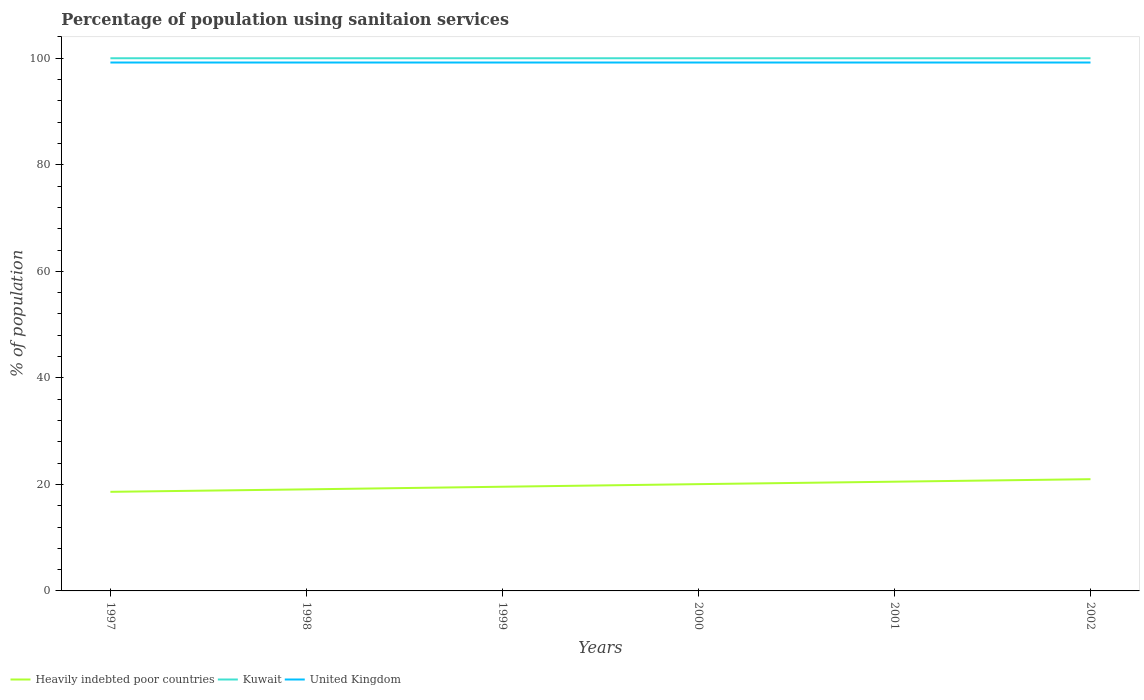Does the line corresponding to Heavily indebted poor countries intersect with the line corresponding to United Kingdom?
Ensure brevity in your answer.  No. Is the number of lines equal to the number of legend labels?
Offer a very short reply. Yes. Across all years, what is the maximum percentage of population using sanitaion services in Kuwait?
Your response must be concise. 100. What is the total percentage of population using sanitaion services in Heavily indebted poor countries in the graph?
Keep it short and to the point. -1.91. What is the difference between the highest and the lowest percentage of population using sanitaion services in Kuwait?
Make the answer very short. 0. Is the percentage of population using sanitaion services in Kuwait strictly greater than the percentage of population using sanitaion services in Heavily indebted poor countries over the years?
Offer a very short reply. No. How many years are there in the graph?
Keep it short and to the point. 6. Are the values on the major ticks of Y-axis written in scientific E-notation?
Provide a short and direct response. No. Does the graph contain any zero values?
Your response must be concise. No. How are the legend labels stacked?
Keep it short and to the point. Horizontal. What is the title of the graph?
Ensure brevity in your answer.  Percentage of population using sanitaion services. Does "Arab World" appear as one of the legend labels in the graph?
Make the answer very short. No. What is the label or title of the X-axis?
Your answer should be compact. Years. What is the label or title of the Y-axis?
Offer a terse response. % of population. What is the % of population in Heavily indebted poor countries in 1997?
Provide a succinct answer. 18.6. What is the % of population of United Kingdom in 1997?
Your response must be concise. 99.2. What is the % of population of Heavily indebted poor countries in 1998?
Offer a very short reply. 19.07. What is the % of population of Kuwait in 1998?
Provide a short and direct response. 100. What is the % of population of United Kingdom in 1998?
Make the answer very short. 99.2. What is the % of population in Heavily indebted poor countries in 1999?
Your answer should be compact. 19.56. What is the % of population of United Kingdom in 1999?
Your response must be concise. 99.2. What is the % of population of Heavily indebted poor countries in 2000?
Keep it short and to the point. 20.05. What is the % of population of Kuwait in 2000?
Your answer should be very brief. 100. What is the % of population in United Kingdom in 2000?
Keep it short and to the point. 99.2. What is the % of population in Heavily indebted poor countries in 2001?
Your answer should be very brief. 20.51. What is the % of population in United Kingdom in 2001?
Make the answer very short. 99.2. What is the % of population in Heavily indebted poor countries in 2002?
Provide a succinct answer. 20.98. What is the % of population in Kuwait in 2002?
Keep it short and to the point. 100. What is the % of population of United Kingdom in 2002?
Keep it short and to the point. 99.2. Across all years, what is the maximum % of population of Heavily indebted poor countries?
Provide a short and direct response. 20.98. Across all years, what is the maximum % of population of Kuwait?
Your answer should be very brief. 100. Across all years, what is the maximum % of population in United Kingdom?
Offer a very short reply. 99.2. Across all years, what is the minimum % of population in Heavily indebted poor countries?
Offer a terse response. 18.6. Across all years, what is the minimum % of population of United Kingdom?
Provide a succinct answer. 99.2. What is the total % of population of Heavily indebted poor countries in the graph?
Your response must be concise. 118.76. What is the total % of population in Kuwait in the graph?
Offer a terse response. 600. What is the total % of population in United Kingdom in the graph?
Your response must be concise. 595.2. What is the difference between the % of population in Heavily indebted poor countries in 1997 and that in 1998?
Ensure brevity in your answer.  -0.46. What is the difference between the % of population of United Kingdom in 1997 and that in 1998?
Provide a succinct answer. 0. What is the difference between the % of population of Heavily indebted poor countries in 1997 and that in 1999?
Your response must be concise. -0.96. What is the difference between the % of population of Heavily indebted poor countries in 1997 and that in 2000?
Offer a very short reply. -1.44. What is the difference between the % of population in Kuwait in 1997 and that in 2000?
Offer a terse response. 0. What is the difference between the % of population of Heavily indebted poor countries in 1997 and that in 2001?
Give a very brief answer. -1.9. What is the difference between the % of population in Kuwait in 1997 and that in 2001?
Keep it short and to the point. 0. What is the difference between the % of population of United Kingdom in 1997 and that in 2001?
Offer a terse response. 0. What is the difference between the % of population of Heavily indebted poor countries in 1997 and that in 2002?
Offer a very short reply. -2.37. What is the difference between the % of population of Kuwait in 1997 and that in 2002?
Offer a terse response. 0. What is the difference between the % of population of Heavily indebted poor countries in 1998 and that in 1999?
Provide a succinct answer. -0.49. What is the difference between the % of population in United Kingdom in 1998 and that in 1999?
Offer a terse response. 0. What is the difference between the % of population in Heavily indebted poor countries in 1998 and that in 2000?
Provide a short and direct response. -0.98. What is the difference between the % of population in United Kingdom in 1998 and that in 2000?
Ensure brevity in your answer.  0. What is the difference between the % of population in Heavily indebted poor countries in 1998 and that in 2001?
Offer a terse response. -1.44. What is the difference between the % of population in Kuwait in 1998 and that in 2001?
Ensure brevity in your answer.  0. What is the difference between the % of population in United Kingdom in 1998 and that in 2001?
Your response must be concise. 0. What is the difference between the % of population in Heavily indebted poor countries in 1998 and that in 2002?
Your answer should be compact. -1.91. What is the difference between the % of population of Kuwait in 1998 and that in 2002?
Give a very brief answer. 0. What is the difference between the % of population in Heavily indebted poor countries in 1999 and that in 2000?
Keep it short and to the point. -0.49. What is the difference between the % of population of Kuwait in 1999 and that in 2000?
Your answer should be compact. 0. What is the difference between the % of population of Heavily indebted poor countries in 1999 and that in 2001?
Provide a succinct answer. -0.95. What is the difference between the % of population of Heavily indebted poor countries in 1999 and that in 2002?
Your answer should be very brief. -1.42. What is the difference between the % of population of United Kingdom in 1999 and that in 2002?
Make the answer very short. 0. What is the difference between the % of population in Heavily indebted poor countries in 2000 and that in 2001?
Offer a terse response. -0.46. What is the difference between the % of population of Heavily indebted poor countries in 2000 and that in 2002?
Your answer should be very brief. -0.93. What is the difference between the % of population of Kuwait in 2000 and that in 2002?
Provide a short and direct response. 0. What is the difference between the % of population of United Kingdom in 2000 and that in 2002?
Offer a very short reply. 0. What is the difference between the % of population of Heavily indebted poor countries in 2001 and that in 2002?
Make the answer very short. -0.47. What is the difference between the % of population of Kuwait in 2001 and that in 2002?
Provide a short and direct response. 0. What is the difference between the % of population in United Kingdom in 2001 and that in 2002?
Provide a short and direct response. 0. What is the difference between the % of population in Heavily indebted poor countries in 1997 and the % of population in Kuwait in 1998?
Your answer should be very brief. -81.4. What is the difference between the % of population in Heavily indebted poor countries in 1997 and the % of population in United Kingdom in 1998?
Give a very brief answer. -80.6. What is the difference between the % of population of Heavily indebted poor countries in 1997 and the % of population of Kuwait in 1999?
Provide a succinct answer. -81.4. What is the difference between the % of population of Heavily indebted poor countries in 1997 and the % of population of United Kingdom in 1999?
Make the answer very short. -80.6. What is the difference between the % of population of Heavily indebted poor countries in 1997 and the % of population of Kuwait in 2000?
Provide a short and direct response. -81.4. What is the difference between the % of population in Heavily indebted poor countries in 1997 and the % of population in United Kingdom in 2000?
Provide a succinct answer. -80.6. What is the difference between the % of population in Kuwait in 1997 and the % of population in United Kingdom in 2000?
Offer a very short reply. 0.8. What is the difference between the % of population of Heavily indebted poor countries in 1997 and the % of population of Kuwait in 2001?
Make the answer very short. -81.4. What is the difference between the % of population of Heavily indebted poor countries in 1997 and the % of population of United Kingdom in 2001?
Ensure brevity in your answer.  -80.6. What is the difference between the % of population of Kuwait in 1997 and the % of population of United Kingdom in 2001?
Your answer should be very brief. 0.8. What is the difference between the % of population in Heavily indebted poor countries in 1997 and the % of population in Kuwait in 2002?
Offer a very short reply. -81.4. What is the difference between the % of population in Heavily indebted poor countries in 1997 and the % of population in United Kingdom in 2002?
Offer a very short reply. -80.6. What is the difference between the % of population in Kuwait in 1997 and the % of population in United Kingdom in 2002?
Offer a terse response. 0.8. What is the difference between the % of population in Heavily indebted poor countries in 1998 and the % of population in Kuwait in 1999?
Keep it short and to the point. -80.93. What is the difference between the % of population of Heavily indebted poor countries in 1998 and the % of population of United Kingdom in 1999?
Offer a terse response. -80.13. What is the difference between the % of population in Heavily indebted poor countries in 1998 and the % of population in Kuwait in 2000?
Provide a short and direct response. -80.93. What is the difference between the % of population of Heavily indebted poor countries in 1998 and the % of population of United Kingdom in 2000?
Offer a very short reply. -80.13. What is the difference between the % of population in Kuwait in 1998 and the % of population in United Kingdom in 2000?
Your answer should be very brief. 0.8. What is the difference between the % of population of Heavily indebted poor countries in 1998 and the % of population of Kuwait in 2001?
Give a very brief answer. -80.93. What is the difference between the % of population in Heavily indebted poor countries in 1998 and the % of population in United Kingdom in 2001?
Offer a terse response. -80.13. What is the difference between the % of population of Heavily indebted poor countries in 1998 and the % of population of Kuwait in 2002?
Make the answer very short. -80.93. What is the difference between the % of population in Heavily indebted poor countries in 1998 and the % of population in United Kingdom in 2002?
Offer a very short reply. -80.13. What is the difference between the % of population in Kuwait in 1998 and the % of population in United Kingdom in 2002?
Ensure brevity in your answer.  0.8. What is the difference between the % of population in Heavily indebted poor countries in 1999 and the % of population in Kuwait in 2000?
Make the answer very short. -80.44. What is the difference between the % of population of Heavily indebted poor countries in 1999 and the % of population of United Kingdom in 2000?
Make the answer very short. -79.64. What is the difference between the % of population in Kuwait in 1999 and the % of population in United Kingdom in 2000?
Provide a short and direct response. 0.8. What is the difference between the % of population in Heavily indebted poor countries in 1999 and the % of population in Kuwait in 2001?
Ensure brevity in your answer.  -80.44. What is the difference between the % of population in Heavily indebted poor countries in 1999 and the % of population in United Kingdom in 2001?
Give a very brief answer. -79.64. What is the difference between the % of population of Kuwait in 1999 and the % of population of United Kingdom in 2001?
Offer a terse response. 0.8. What is the difference between the % of population in Heavily indebted poor countries in 1999 and the % of population in Kuwait in 2002?
Make the answer very short. -80.44. What is the difference between the % of population of Heavily indebted poor countries in 1999 and the % of population of United Kingdom in 2002?
Provide a short and direct response. -79.64. What is the difference between the % of population in Kuwait in 1999 and the % of population in United Kingdom in 2002?
Your answer should be compact. 0.8. What is the difference between the % of population of Heavily indebted poor countries in 2000 and the % of population of Kuwait in 2001?
Your answer should be compact. -79.95. What is the difference between the % of population in Heavily indebted poor countries in 2000 and the % of population in United Kingdom in 2001?
Provide a succinct answer. -79.15. What is the difference between the % of population in Heavily indebted poor countries in 2000 and the % of population in Kuwait in 2002?
Your answer should be compact. -79.95. What is the difference between the % of population of Heavily indebted poor countries in 2000 and the % of population of United Kingdom in 2002?
Ensure brevity in your answer.  -79.15. What is the difference between the % of population of Heavily indebted poor countries in 2001 and the % of population of Kuwait in 2002?
Your answer should be compact. -79.49. What is the difference between the % of population of Heavily indebted poor countries in 2001 and the % of population of United Kingdom in 2002?
Your response must be concise. -78.69. What is the difference between the % of population of Kuwait in 2001 and the % of population of United Kingdom in 2002?
Ensure brevity in your answer.  0.8. What is the average % of population in Heavily indebted poor countries per year?
Make the answer very short. 19.79. What is the average % of population in United Kingdom per year?
Your response must be concise. 99.2. In the year 1997, what is the difference between the % of population in Heavily indebted poor countries and % of population in Kuwait?
Offer a terse response. -81.4. In the year 1997, what is the difference between the % of population of Heavily indebted poor countries and % of population of United Kingdom?
Offer a very short reply. -80.6. In the year 1998, what is the difference between the % of population of Heavily indebted poor countries and % of population of Kuwait?
Keep it short and to the point. -80.93. In the year 1998, what is the difference between the % of population of Heavily indebted poor countries and % of population of United Kingdom?
Your answer should be very brief. -80.13. In the year 1999, what is the difference between the % of population in Heavily indebted poor countries and % of population in Kuwait?
Your response must be concise. -80.44. In the year 1999, what is the difference between the % of population in Heavily indebted poor countries and % of population in United Kingdom?
Your response must be concise. -79.64. In the year 2000, what is the difference between the % of population of Heavily indebted poor countries and % of population of Kuwait?
Ensure brevity in your answer.  -79.95. In the year 2000, what is the difference between the % of population in Heavily indebted poor countries and % of population in United Kingdom?
Your answer should be very brief. -79.15. In the year 2001, what is the difference between the % of population in Heavily indebted poor countries and % of population in Kuwait?
Keep it short and to the point. -79.49. In the year 2001, what is the difference between the % of population of Heavily indebted poor countries and % of population of United Kingdom?
Offer a very short reply. -78.69. In the year 2002, what is the difference between the % of population in Heavily indebted poor countries and % of population in Kuwait?
Give a very brief answer. -79.02. In the year 2002, what is the difference between the % of population in Heavily indebted poor countries and % of population in United Kingdom?
Your response must be concise. -78.22. What is the ratio of the % of population in Heavily indebted poor countries in 1997 to that in 1998?
Your response must be concise. 0.98. What is the ratio of the % of population in Kuwait in 1997 to that in 1998?
Ensure brevity in your answer.  1. What is the ratio of the % of population of Heavily indebted poor countries in 1997 to that in 1999?
Your answer should be compact. 0.95. What is the ratio of the % of population in Kuwait in 1997 to that in 1999?
Ensure brevity in your answer.  1. What is the ratio of the % of population of Heavily indebted poor countries in 1997 to that in 2000?
Your response must be concise. 0.93. What is the ratio of the % of population in Heavily indebted poor countries in 1997 to that in 2001?
Offer a terse response. 0.91. What is the ratio of the % of population of Heavily indebted poor countries in 1997 to that in 2002?
Provide a succinct answer. 0.89. What is the ratio of the % of population in Heavily indebted poor countries in 1998 to that in 1999?
Ensure brevity in your answer.  0.97. What is the ratio of the % of population in United Kingdom in 1998 to that in 1999?
Give a very brief answer. 1. What is the ratio of the % of population of Heavily indebted poor countries in 1998 to that in 2000?
Your response must be concise. 0.95. What is the ratio of the % of population of Kuwait in 1998 to that in 2000?
Your response must be concise. 1. What is the ratio of the % of population in Heavily indebted poor countries in 1998 to that in 2001?
Keep it short and to the point. 0.93. What is the ratio of the % of population in Kuwait in 1998 to that in 2001?
Make the answer very short. 1. What is the ratio of the % of population of United Kingdom in 1998 to that in 2001?
Provide a succinct answer. 1. What is the ratio of the % of population in Heavily indebted poor countries in 1998 to that in 2002?
Your response must be concise. 0.91. What is the ratio of the % of population of Heavily indebted poor countries in 1999 to that in 2000?
Make the answer very short. 0.98. What is the ratio of the % of population in Kuwait in 1999 to that in 2000?
Make the answer very short. 1. What is the ratio of the % of population of Heavily indebted poor countries in 1999 to that in 2001?
Make the answer very short. 0.95. What is the ratio of the % of population in United Kingdom in 1999 to that in 2001?
Offer a very short reply. 1. What is the ratio of the % of population in Heavily indebted poor countries in 1999 to that in 2002?
Make the answer very short. 0.93. What is the ratio of the % of population in Kuwait in 1999 to that in 2002?
Your answer should be very brief. 1. What is the ratio of the % of population of United Kingdom in 1999 to that in 2002?
Make the answer very short. 1. What is the ratio of the % of population of Heavily indebted poor countries in 2000 to that in 2001?
Your response must be concise. 0.98. What is the ratio of the % of population in Heavily indebted poor countries in 2000 to that in 2002?
Ensure brevity in your answer.  0.96. What is the ratio of the % of population of Kuwait in 2000 to that in 2002?
Your answer should be very brief. 1. What is the ratio of the % of population in United Kingdom in 2000 to that in 2002?
Ensure brevity in your answer.  1. What is the ratio of the % of population in Heavily indebted poor countries in 2001 to that in 2002?
Your response must be concise. 0.98. What is the ratio of the % of population of Kuwait in 2001 to that in 2002?
Your response must be concise. 1. What is the difference between the highest and the second highest % of population in Heavily indebted poor countries?
Keep it short and to the point. 0.47. What is the difference between the highest and the second highest % of population of United Kingdom?
Ensure brevity in your answer.  0. What is the difference between the highest and the lowest % of population of Heavily indebted poor countries?
Offer a terse response. 2.37. What is the difference between the highest and the lowest % of population in Kuwait?
Your response must be concise. 0. What is the difference between the highest and the lowest % of population of United Kingdom?
Your answer should be very brief. 0. 